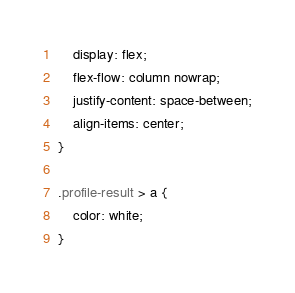Convert code to text. <code><loc_0><loc_0><loc_500><loc_500><_CSS_>    display: flex;
    flex-flow: column nowrap;
    justify-content: space-between;
    align-items: center;
}

.profile-result > a {
    color: white;
}
</code> 